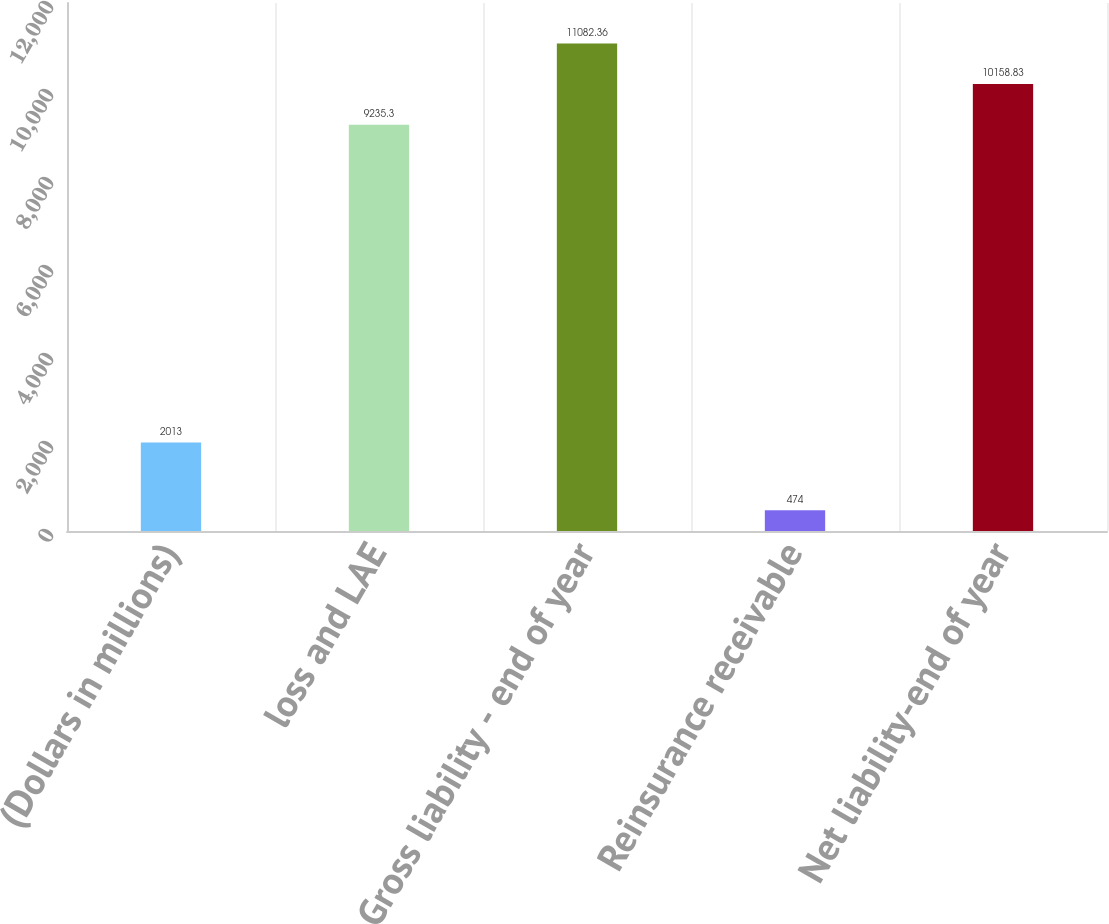Convert chart to OTSL. <chart><loc_0><loc_0><loc_500><loc_500><bar_chart><fcel>(Dollars in millions)<fcel>loss and LAE<fcel>Gross liability - end of year<fcel>Reinsurance receivable<fcel>Net liability-end of year<nl><fcel>2013<fcel>9235.3<fcel>11082.4<fcel>474<fcel>10158.8<nl></chart> 